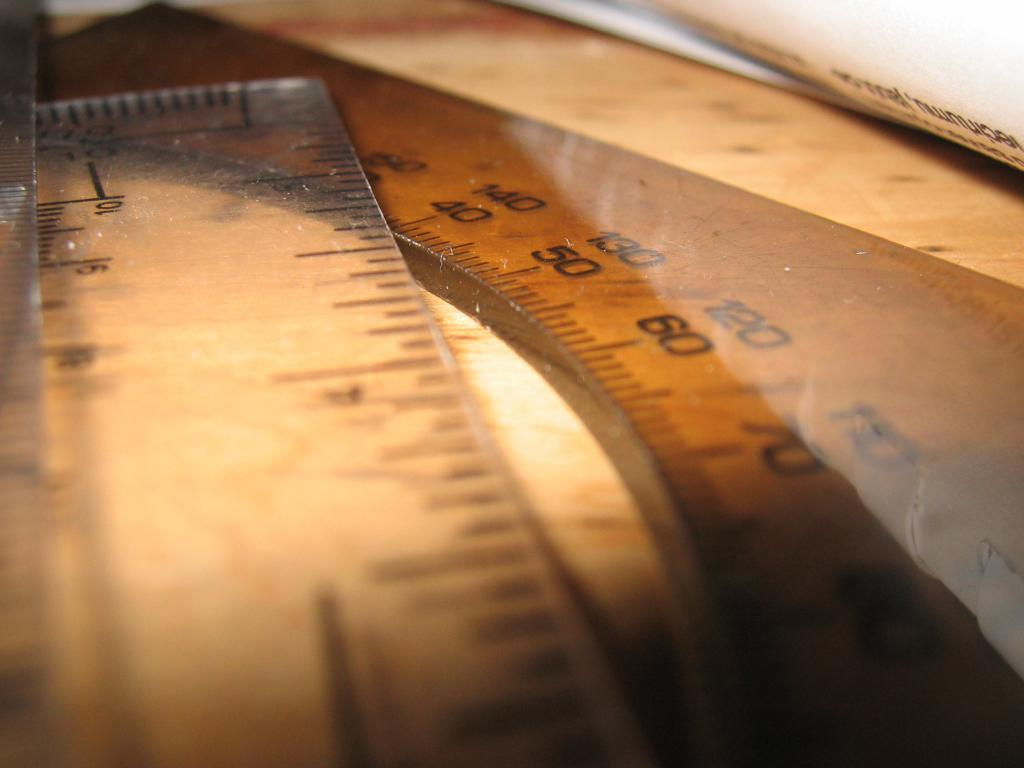<image>
Present a compact description of the photo's key features. 3 inches of a plastic ruler placed over a curved ruler of about 90 centimeters. 